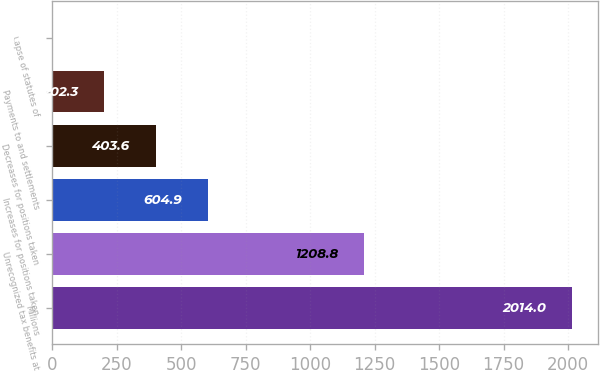Convert chart to OTSL. <chart><loc_0><loc_0><loc_500><loc_500><bar_chart><fcel>Millions<fcel>Unrecognized tax benefits at<fcel>Increases for positions taken<fcel>Decreases for positions taken<fcel>Payments to and settlements<fcel>Lapse of statutes of<nl><fcel>2014<fcel>1208.8<fcel>604.9<fcel>403.6<fcel>202.3<fcel>1<nl></chart> 